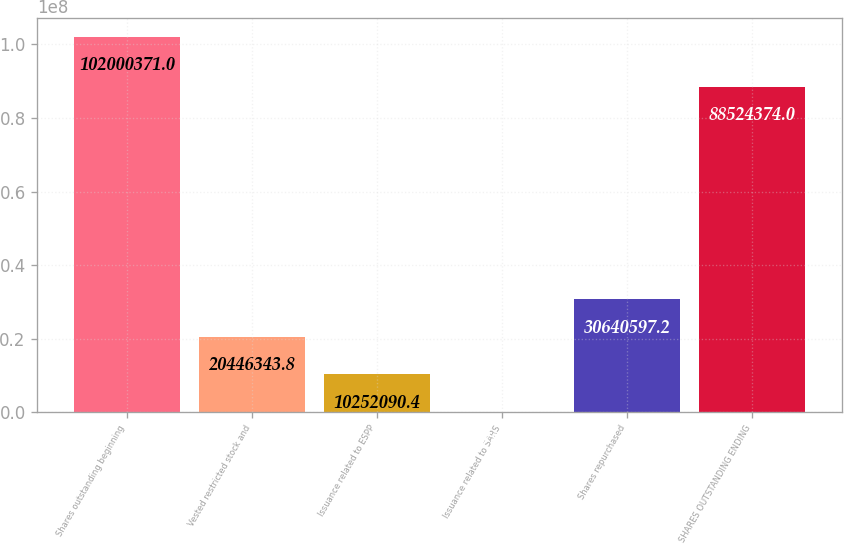Convert chart. <chart><loc_0><loc_0><loc_500><loc_500><bar_chart><fcel>Shares outstanding beginning<fcel>Vested restricted stock and<fcel>Issuance related to ESPP<fcel>Issuance related to SARS<fcel>Shares repurchased<fcel>SHARES OUTSTANDING ENDING<nl><fcel>1.02e+08<fcel>2.04463e+07<fcel>1.02521e+07<fcel>57837<fcel>3.06406e+07<fcel>8.85244e+07<nl></chart> 